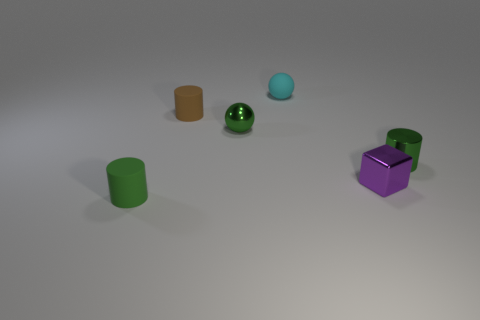Does the tiny metal cylinder have the same color as the tiny rubber cylinder in front of the tiny green metal ball?
Your answer should be very brief. Yes. There is a cylinder to the right of the green shiny sphere; is its color the same as the small shiny sphere?
Ensure brevity in your answer.  Yes. What material is the tiny ball that is the same color as the shiny cylinder?
Your answer should be very brief. Metal. How many tiny metallic objects are the same color as the tiny metallic cylinder?
Give a very brief answer. 1. The ball that is the same color as the tiny metal cylinder is what size?
Ensure brevity in your answer.  Small. What is the cylinder that is both to the left of the small purple cube and in front of the small brown rubber thing made of?
Your answer should be very brief. Rubber. Are there any small green rubber cylinders to the right of the tiny brown rubber thing?
Provide a succinct answer. No. The green object that is made of the same material as the cyan sphere is what size?
Your answer should be compact. Small. How many other small rubber objects have the same shape as the small brown matte object?
Your answer should be compact. 1. Is the cyan ball made of the same material as the green thing in front of the green metallic cylinder?
Your answer should be compact. Yes. 